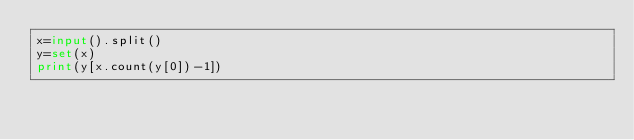<code> <loc_0><loc_0><loc_500><loc_500><_Python_>x=input().split()
y=set(x)
print(y[x.count(y[0])-1])</code> 